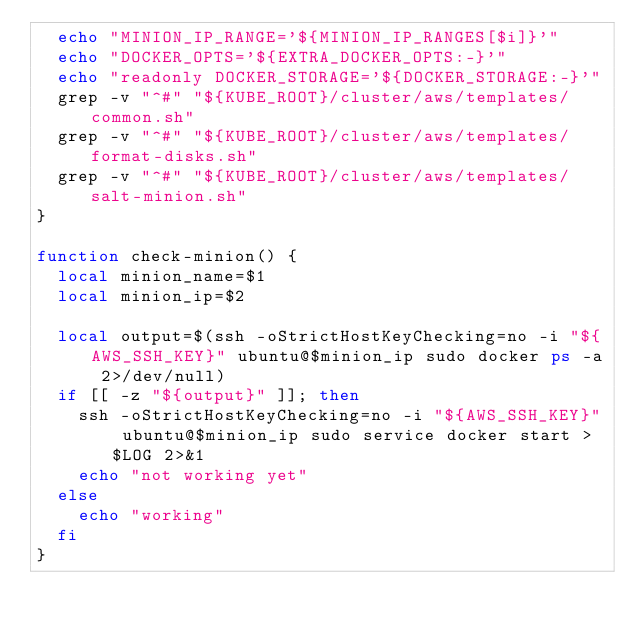Convert code to text. <code><loc_0><loc_0><loc_500><loc_500><_Bash_>  echo "MINION_IP_RANGE='${MINION_IP_RANGES[$i]}'"
  echo "DOCKER_OPTS='${EXTRA_DOCKER_OPTS:-}'"
  echo "readonly DOCKER_STORAGE='${DOCKER_STORAGE:-}'"
  grep -v "^#" "${KUBE_ROOT}/cluster/aws/templates/common.sh"
  grep -v "^#" "${KUBE_ROOT}/cluster/aws/templates/format-disks.sh"
  grep -v "^#" "${KUBE_ROOT}/cluster/aws/templates/salt-minion.sh"
}

function check-minion() {
  local minion_name=$1
  local minion_ip=$2

  local output=$(ssh -oStrictHostKeyChecking=no -i "${AWS_SSH_KEY}" ubuntu@$minion_ip sudo docker ps -a 2>/dev/null)
  if [[ -z "${output}" ]]; then
    ssh -oStrictHostKeyChecking=no -i "${AWS_SSH_KEY}" ubuntu@$minion_ip sudo service docker start > $LOG 2>&1
    echo "not working yet"
  else
    echo "working"
  fi
}
</code> 